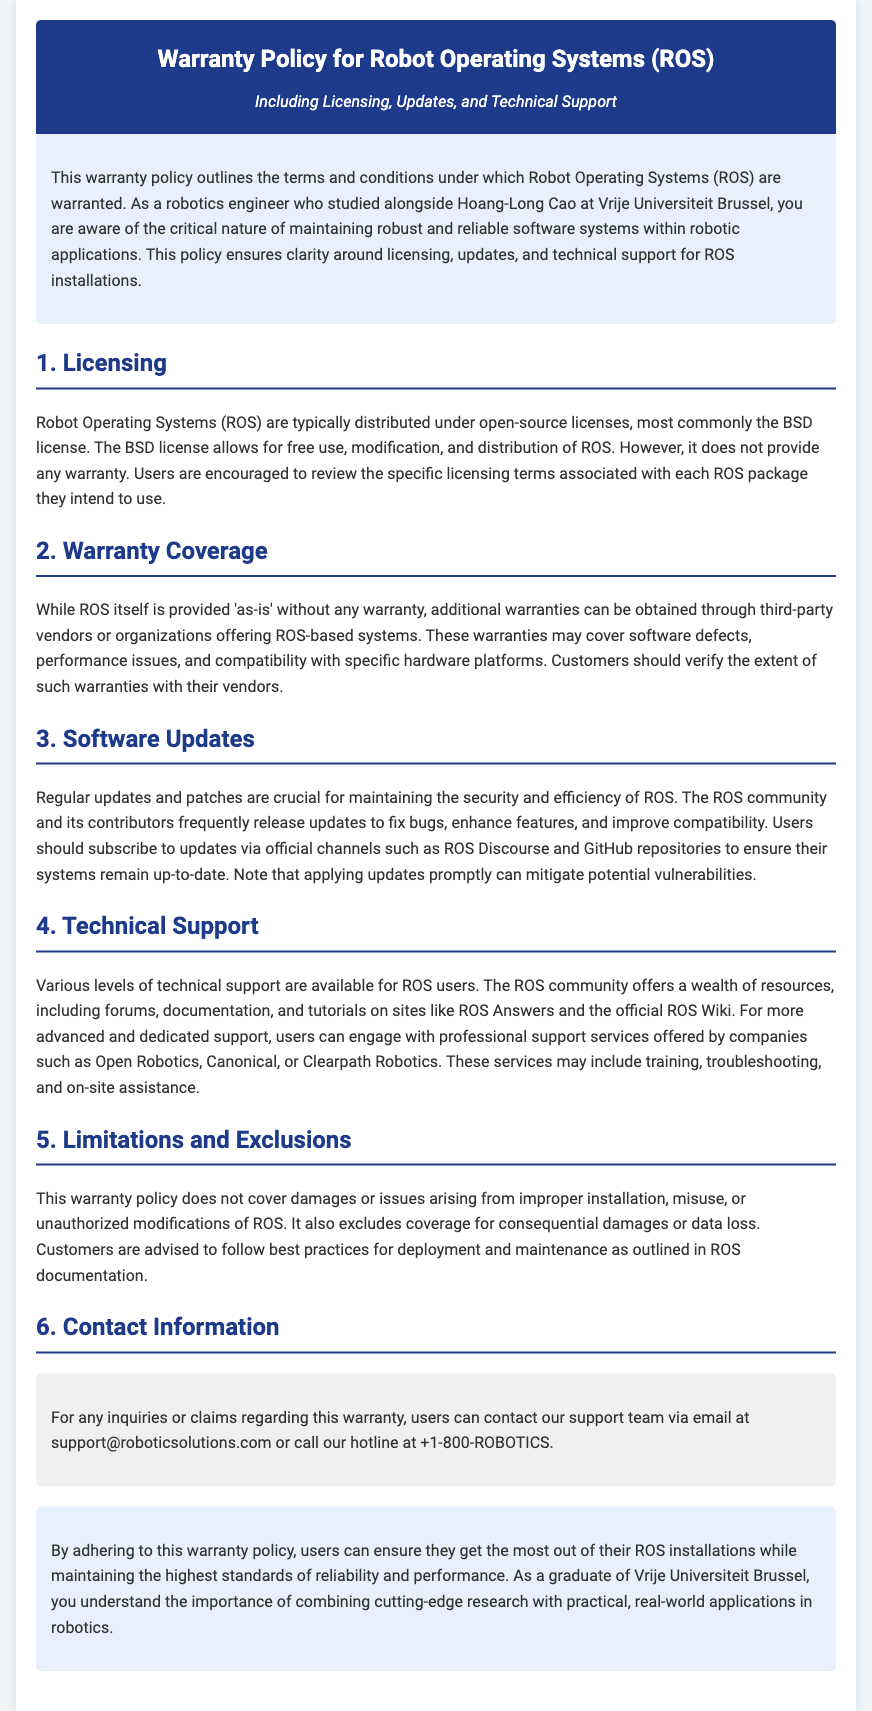What is the main purpose of the warranty policy? The introduction outlines that the warranty policy ensures clarity around licensing, updates, and technical support for ROS installations.
Answer: clarity around licensing, updates, and technical support What open-source license is most commonly used for ROS? The document states that ROS is typically distributed under the BSD license.
Answer: BSD license What must users do to ensure their systems remain up-to-date? The section on Software Updates advises users to subscribe to updates via official channels such as ROS Discourse and GitHub repositories.
Answer: subscribe to updates via official channels Who provides technical support for ROS users? The section on Technical Support mentions that various levels of support are available from the ROS community and companies like Open Robotics and Canonical.
Answer: Open Robotics and Canonical What issues are not covered by this warranty policy? The section on Limitations and Exclusions states that damages arising from improper installation, misuse, or unauthorized modifications are not covered.
Answer: improper installation, misuse, or unauthorized modifications How can users inquire about the warranty? The section on Contact Information provides an email address and a hotline for inquiries or claims regarding the warranty.
Answer: support@roboticsolutions.com or call +1-800-ROBOTICS What does the warranty policy not provide? The document specifies that ROS is provided ‘as-is’ without any warranty.
Answer: any warranty What is emphasized as important for maintaining reliable ROS installations? The conclusion underlines that users should adhere to the warranty policy for optimal reliability and performance of their ROS installations.
Answer: adhere to warranty policy for optimal reliability and performance 